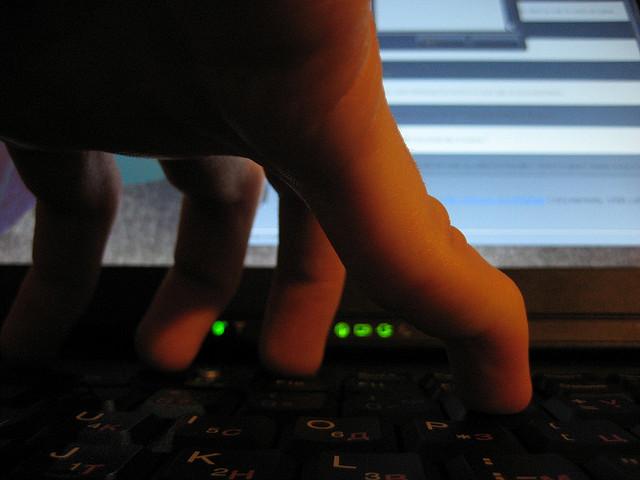Are the fingers normal?
Be succinct. Yes. What are the fingers touching?
Be succinct. Keyboard. Why is his fingers so big?
Be succinct. Perspective. 